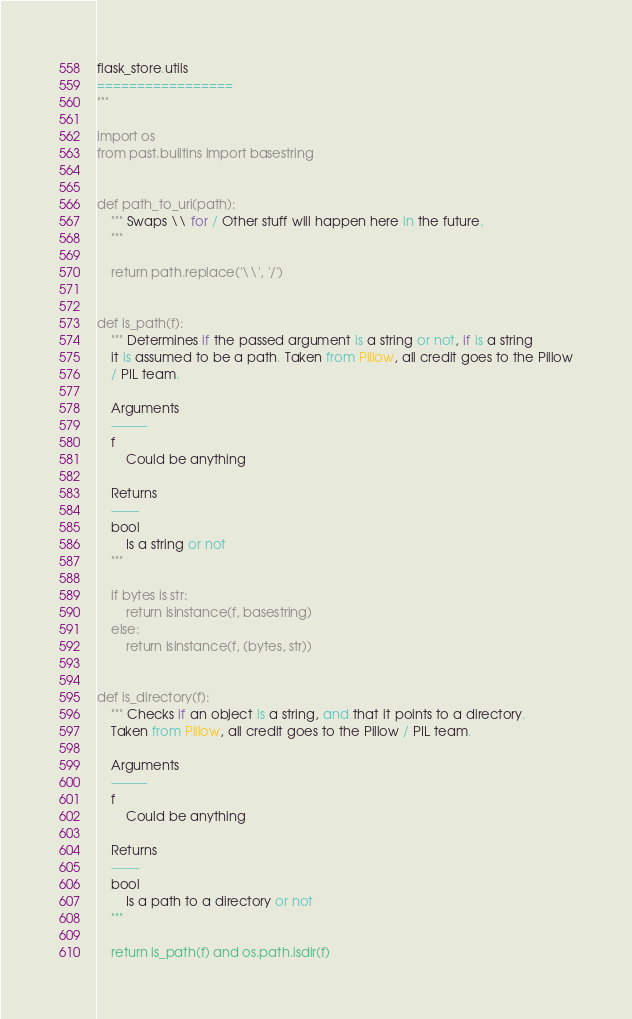Convert code to text. <code><loc_0><loc_0><loc_500><loc_500><_Python_>flask_store.utils
=================
"""

import os
from past.builtins import basestring


def path_to_uri(path):
    """ Swaps \\ for / Other stuff will happen here in the future.
    """

    return path.replace('\\', '/')


def is_path(f):
    """ Determines if the passed argument is a string or not, if is a string
    it is assumed to be a path. Taken from Pillow, all credit goes to the Pillow
    / PIL team.

    Arguments
    ---------
    f
        Could be anything

    Returns
    -------
    bool
        Is a string or not
    """

    if bytes is str:
        return isinstance(f, basestring)
    else:
        return isinstance(f, (bytes, str))


def is_directory(f):
    """ Checks if an object is a string, and that it points to a directory.
    Taken from Pillow, all credit goes to the Pillow / PIL team.

    Arguments
    ---------
    f
        Could be anything

    Returns
    -------
    bool
        Is a path to a directory or not
    """

    return is_path(f) and os.path.isdir(f)
</code> 